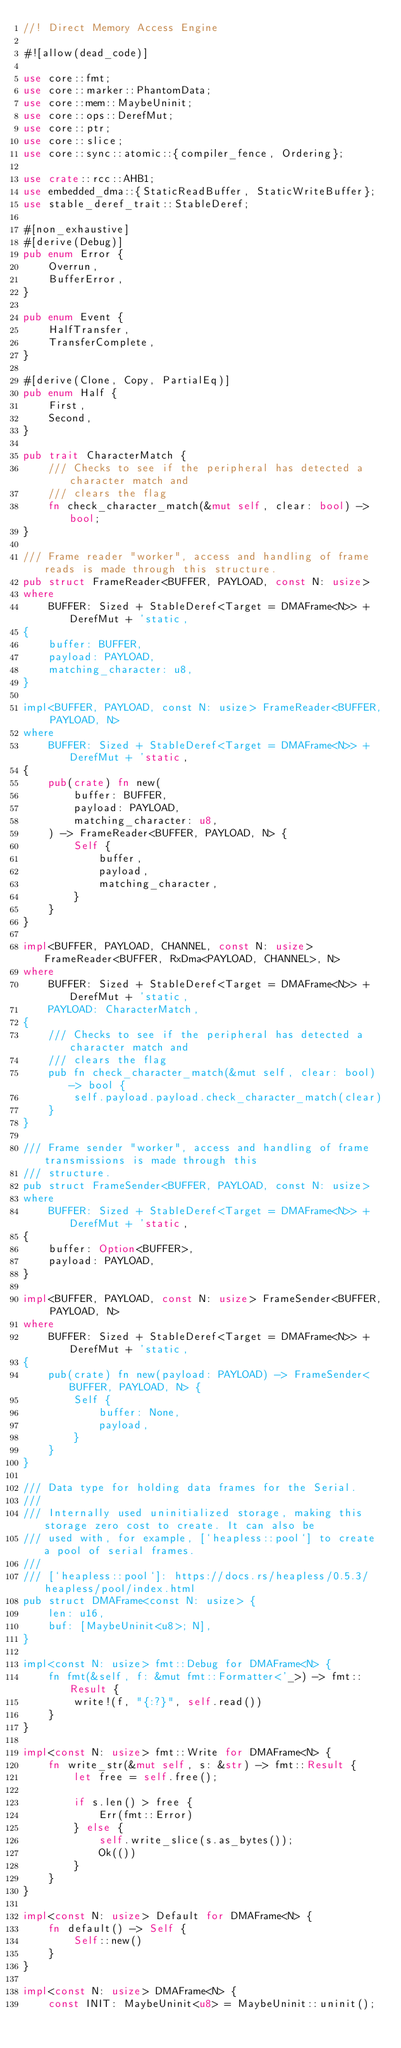Convert code to text. <code><loc_0><loc_0><loc_500><loc_500><_Rust_>//! Direct Memory Access Engine

#![allow(dead_code)]

use core::fmt;
use core::marker::PhantomData;
use core::mem::MaybeUninit;
use core::ops::DerefMut;
use core::ptr;
use core::slice;
use core::sync::atomic::{compiler_fence, Ordering};

use crate::rcc::AHB1;
use embedded_dma::{StaticReadBuffer, StaticWriteBuffer};
use stable_deref_trait::StableDeref;

#[non_exhaustive]
#[derive(Debug)]
pub enum Error {
    Overrun,
    BufferError,
}

pub enum Event {
    HalfTransfer,
    TransferComplete,
}

#[derive(Clone, Copy, PartialEq)]
pub enum Half {
    First,
    Second,
}

pub trait CharacterMatch {
    /// Checks to see if the peripheral has detected a character match and
    /// clears the flag
    fn check_character_match(&mut self, clear: bool) -> bool;
}

/// Frame reader "worker", access and handling of frame reads is made through this structure.
pub struct FrameReader<BUFFER, PAYLOAD, const N: usize>
where
    BUFFER: Sized + StableDeref<Target = DMAFrame<N>> + DerefMut + 'static,
{
    buffer: BUFFER,
    payload: PAYLOAD,
    matching_character: u8,
}

impl<BUFFER, PAYLOAD, const N: usize> FrameReader<BUFFER, PAYLOAD, N>
where
    BUFFER: Sized + StableDeref<Target = DMAFrame<N>> + DerefMut + 'static,
{
    pub(crate) fn new(
        buffer: BUFFER,
        payload: PAYLOAD,
        matching_character: u8,
    ) -> FrameReader<BUFFER, PAYLOAD, N> {
        Self {
            buffer,
            payload,
            matching_character,
        }
    }
}

impl<BUFFER, PAYLOAD, CHANNEL, const N: usize> FrameReader<BUFFER, RxDma<PAYLOAD, CHANNEL>, N>
where
    BUFFER: Sized + StableDeref<Target = DMAFrame<N>> + DerefMut + 'static,
    PAYLOAD: CharacterMatch,
{
    /// Checks to see if the peripheral has detected a character match and
    /// clears the flag
    pub fn check_character_match(&mut self, clear: bool) -> bool {
        self.payload.payload.check_character_match(clear)
    }
}

/// Frame sender "worker", access and handling of frame transmissions is made through this
/// structure.
pub struct FrameSender<BUFFER, PAYLOAD, const N: usize>
where
    BUFFER: Sized + StableDeref<Target = DMAFrame<N>> + DerefMut + 'static,
{
    buffer: Option<BUFFER>,
    payload: PAYLOAD,
}

impl<BUFFER, PAYLOAD, const N: usize> FrameSender<BUFFER, PAYLOAD, N>
where
    BUFFER: Sized + StableDeref<Target = DMAFrame<N>> + DerefMut + 'static,
{
    pub(crate) fn new(payload: PAYLOAD) -> FrameSender<BUFFER, PAYLOAD, N> {
        Self {
            buffer: None,
            payload,
        }
    }
}

/// Data type for holding data frames for the Serial.
///
/// Internally used uninitialized storage, making this storage zero cost to create. It can also be
/// used with, for example, [`heapless::pool`] to create a pool of serial frames.
///
/// [`heapless::pool`]: https://docs.rs/heapless/0.5.3/heapless/pool/index.html
pub struct DMAFrame<const N: usize> {
    len: u16,
    buf: [MaybeUninit<u8>; N],
}

impl<const N: usize> fmt::Debug for DMAFrame<N> {
    fn fmt(&self, f: &mut fmt::Formatter<'_>) -> fmt::Result {
        write!(f, "{:?}", self.read())
    }
}

impl<const N: usize> fmt::Write for DMAFrame<N> {
    fn write_str(&mut self, s: &str) -> fmt::Result {
        let free = self.free();

        if s.len() > free {
            Err(fmt::Error)
        } else {
            self.write_slice(s.as_bytes());
            Ok(())
        }
    }
}

impl<const N: usize> Default for DMAFrame<N> {
    fn default() -> Self {
        Self::new()
    }
}

impl<const N: usize> DMAFrame<N> {
    const INIT: MaybeUninit<u8> = MaybeUninit::uninit();</code> 